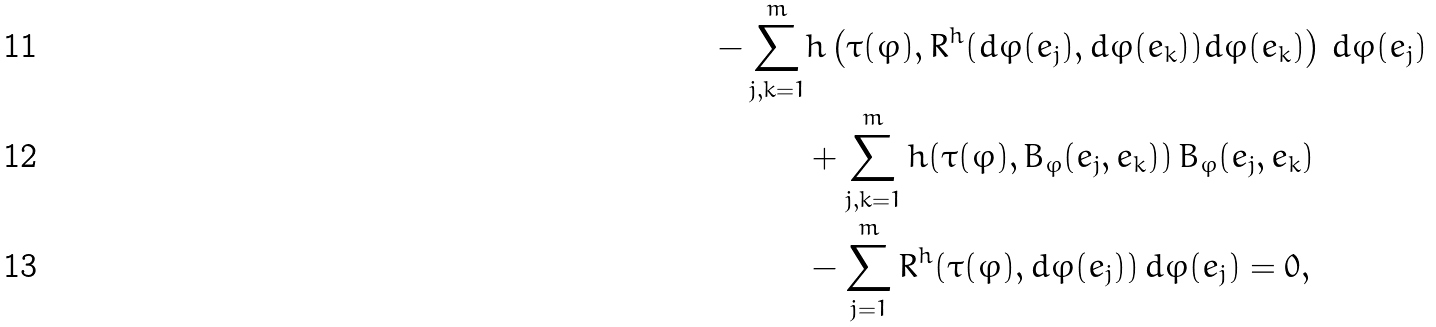Convert formula to latex. <formula><loc_0><loc_0><loc_500><loc_500>- \sum _ { j , k = 1 } ^ { m } & h \left ( \tau ( \varphi ) , R ^ { h } ( d \varphi ( e _ { j } ) , d \varphi ( e _ { k } ) ) d \varphi ( e _ { k } ) \right ) \, d \varphi ( e _ { j } ) \\ & + \sum _ { j , k = 1 } ^ { m } h ( \tau ( \varphi ) , B _ { \varphi } ( e _ { j } , e _ { k } ) ) \, B _ { \varphi } ( e _ { j } , e _ { k } ) \\ & - \sum _ { j = 1 } ^ { m } R ^ { h } ( \tau ( \varphi ) , d \varphi ( e _ { j } ) ) \, d \varphi ( e _ { j } ) = 0 ,</formula> 